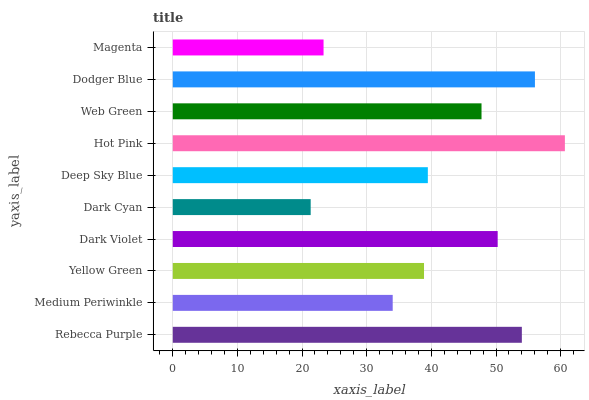Is Dark Cyan the minimum?
Answer yes or no. Yes. Is Hot Pink the maximum?
Answer yes or no. Yes. Is Medium Periwinkle the minimum?
Answer yes or no. No. Is Medium Periwinkle the maximum?
Answer yes or no. No. Is Rebecca Purple greater than Medium Periwinkle?
Answer yes or no. Yes. Is Medium Periwinkle less than Rebecca Purple?
Answer yes or no. Yes. Is Medium Periwinkle greater than Rebecca Purple?
Answer yes or no. No. Is Rebecca Purple less than Medium Periwinkle?
Answer yes or no. No. Is Web Green the high median?
Answer yes or no. Yes. Is Deep Sky Blue the low median?
Answer yes or no. Yes. Is Medium Periwinkle the high median?
Answer yes or no. No. Is Dodger Blue the low median?
Answer yes or no. No. 